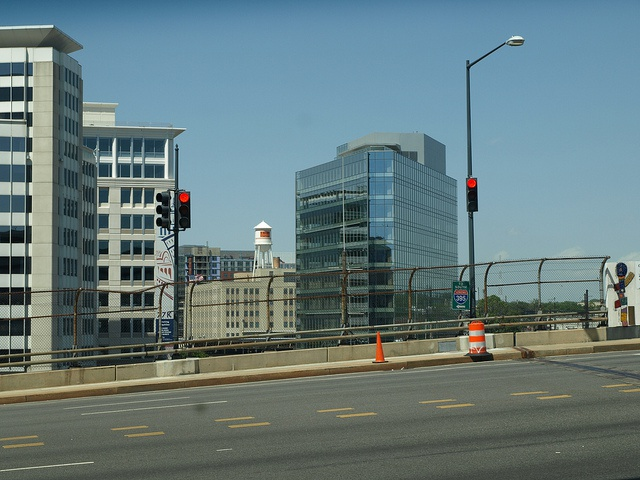Describe the objects in this image and their specific colors. I can see traffic light in blue, black, gray, darkgray, and purple tones, traffic light in blue, black, red, gray, and purple tones, and traffic light in blue, black, red, and purple tones in this image. 